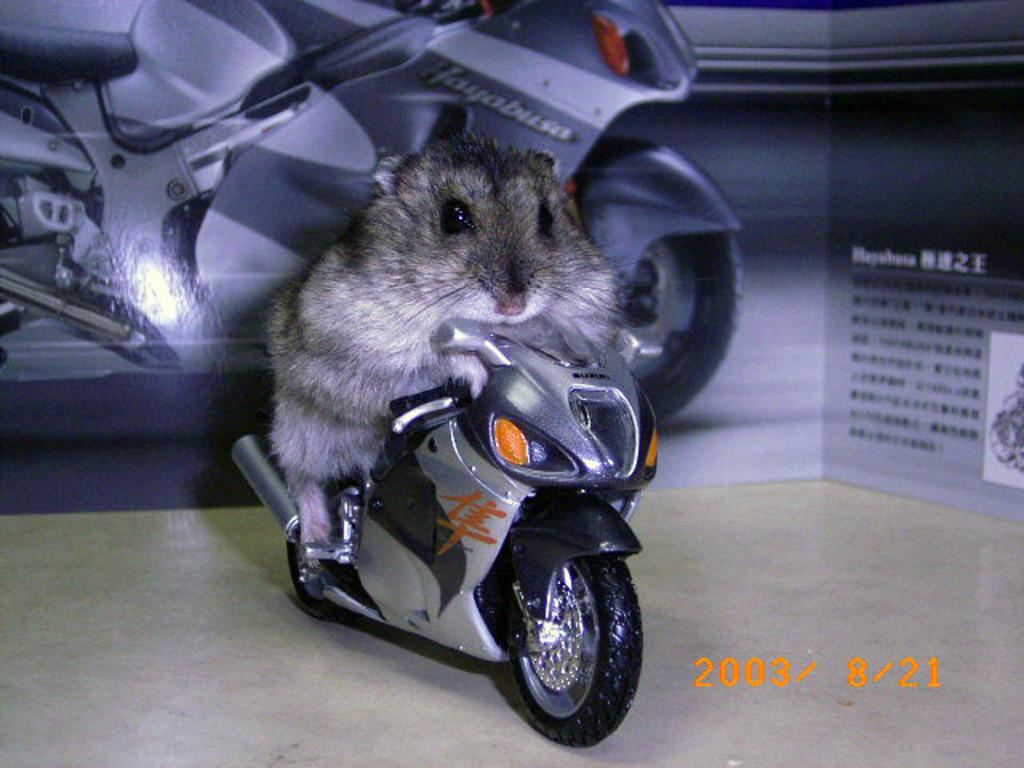What is the main subject of the image? There is a mouse in the image. What is the mouse doing in the image? The mouse is on a bike. Can you describe any other elements in the background of the image? There is a photo of a bike in the background of the image. What type of history lesson can be learned from the image? The image does not depict a history lesson or any historical events, so no history lesson can be learned from it. 